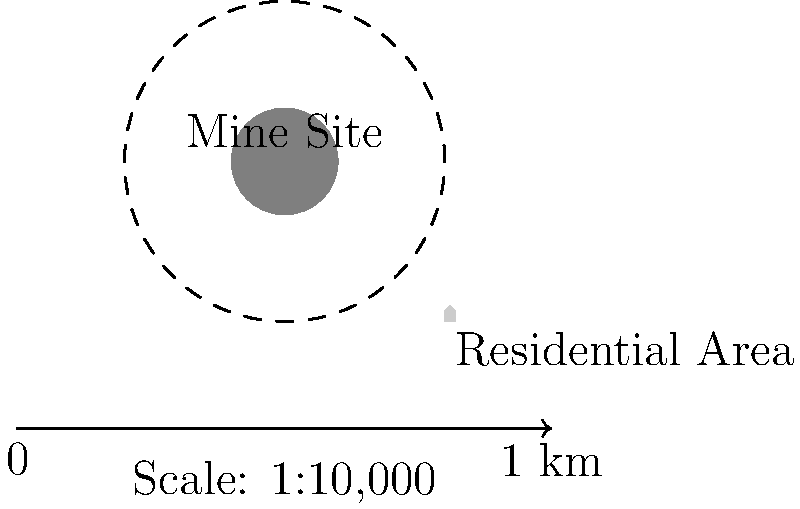Using the scale map provided, determine the minimum buffer zone distance required between the mine site and the residential area. The scale of the map is 1:10,000, and each unit on the map represents 1 km in real distance. What is the buffer zone distance in meters? To solve this problem, we'll follow these steps:

1. Identify the scale: The map scale is 1:10,000, meaning 1 unit on the map represents 10,000 units in real distance.

2. Measure the buffer zone on the map:
   The buffer zone is represented by the dashed circle around the mine site.
   The radius of this circle is 3 units on the map.

3. Convert map distance to real distance:
   - 1 unit on the map = 1 km in real distance
   - Buffer zone radius = 3 units
   - Real distance = 3 km

4. Convert kilometers to meters:
   $3 \text{ km} = 3 \times 1000 \text{ m} = 3000 \text{ m}$

Therefore, the buffer zone distance between the mine site and residential area is 3000 meters.
Answer: 3000 meters 